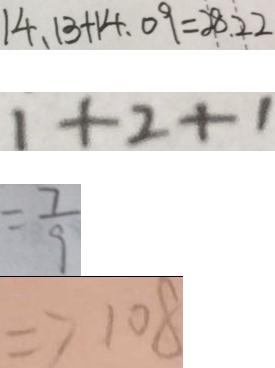<formula> <loc_0><loc_0><loc_500><loc_500>1 4 . 1 3 + 1 4 . 0 9 = 2 8 . 2 2 
 1 + 2 + 1 
 = \frac { 7 } { 9 } 
 \Rightarrow 1 0 8</formula> 